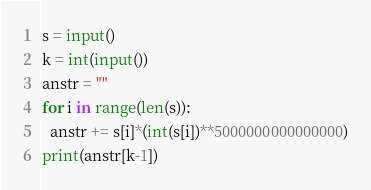<code> <loc_0><loc_0><loc_500><loc_500><_Python_>s = input()
k = int(input())
anstr = ""
for i in range(len(s)):
  anstr += s[i]*(int(s[i])**5000000000000000)
print(anstr[k-1])</code> 